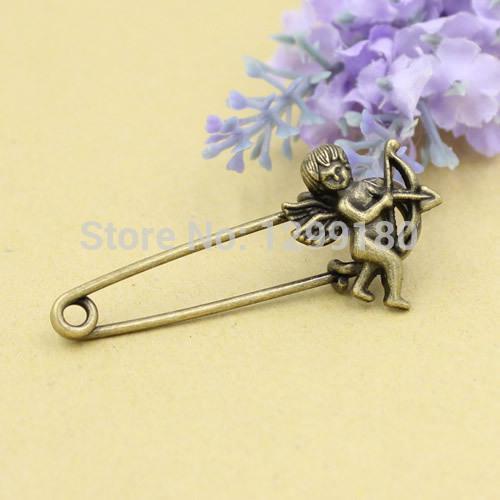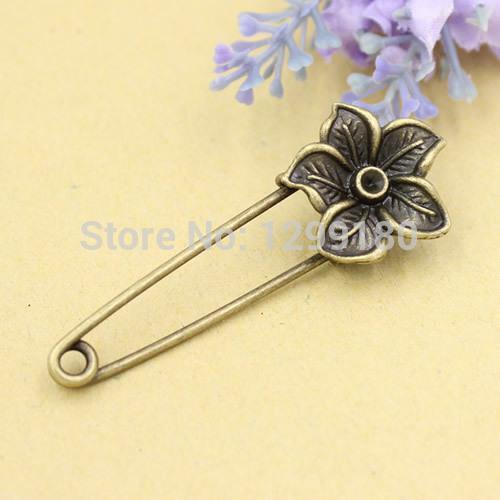The first image is the image on the left, the second image is the image on the right. Evaluate the accuracy of this statement regarding the images: "Each photo contains a single safety pin with a decorative clasp.". Is it true? Answer yes or no. Yes. 